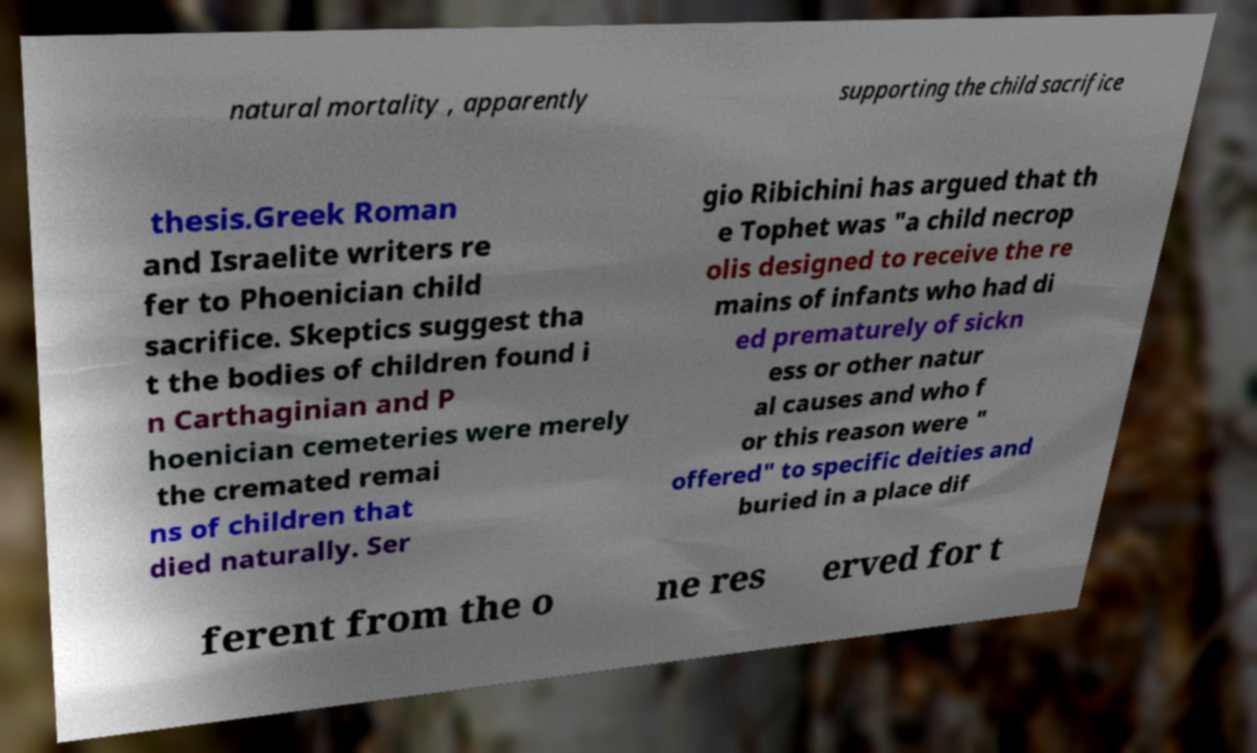I need the written content from this picture converted into text. Can you do that? natural mortality , apparently supporting the child sacrifice thesis.Greek Roman and Israelite writers re fer to Phoenician child sacrifice. Skeptics suggest tha t the bodies of children found i n Carthaginian and P hoenician cemeteries were merely the cremated remai ns of children that died naturally. Ser gio Ribichini has argued that th e Tophet was "a child necrop olis designed to receive the re mains of infants who had di ed prematurely of sickn ess or other natur al causes and who f or this reason were " offered" to specific deities and buried in a place dif ferent from the o ne res erved for t 